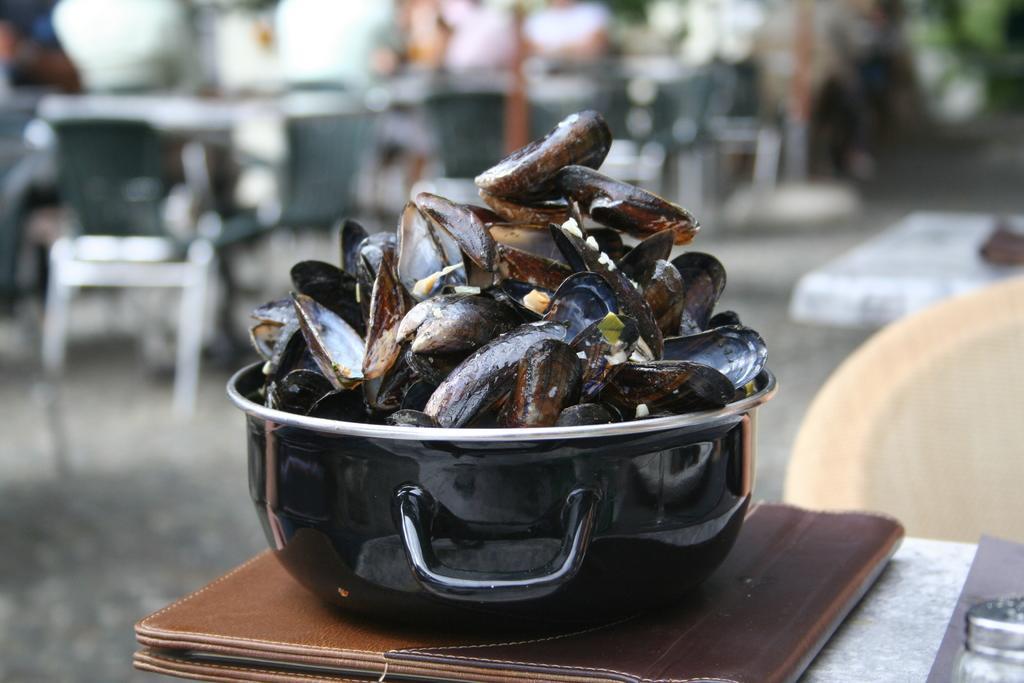Can you describe this image briefly? In this image, I can see a casserole with mussels and a file, which are placed on the table. There is a blurred background. 